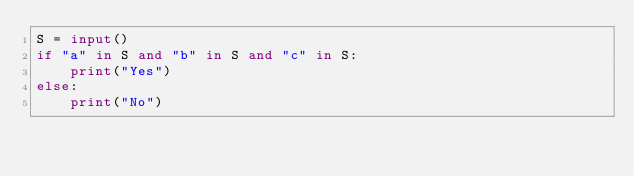Convert code to text. <code><loc_0><loc_0><loc_500><loc_500><_Python_>S = input()
if "a" in S and "b" in S and "c" in S:
    print("Yes")
else:
    print("No")</code> 